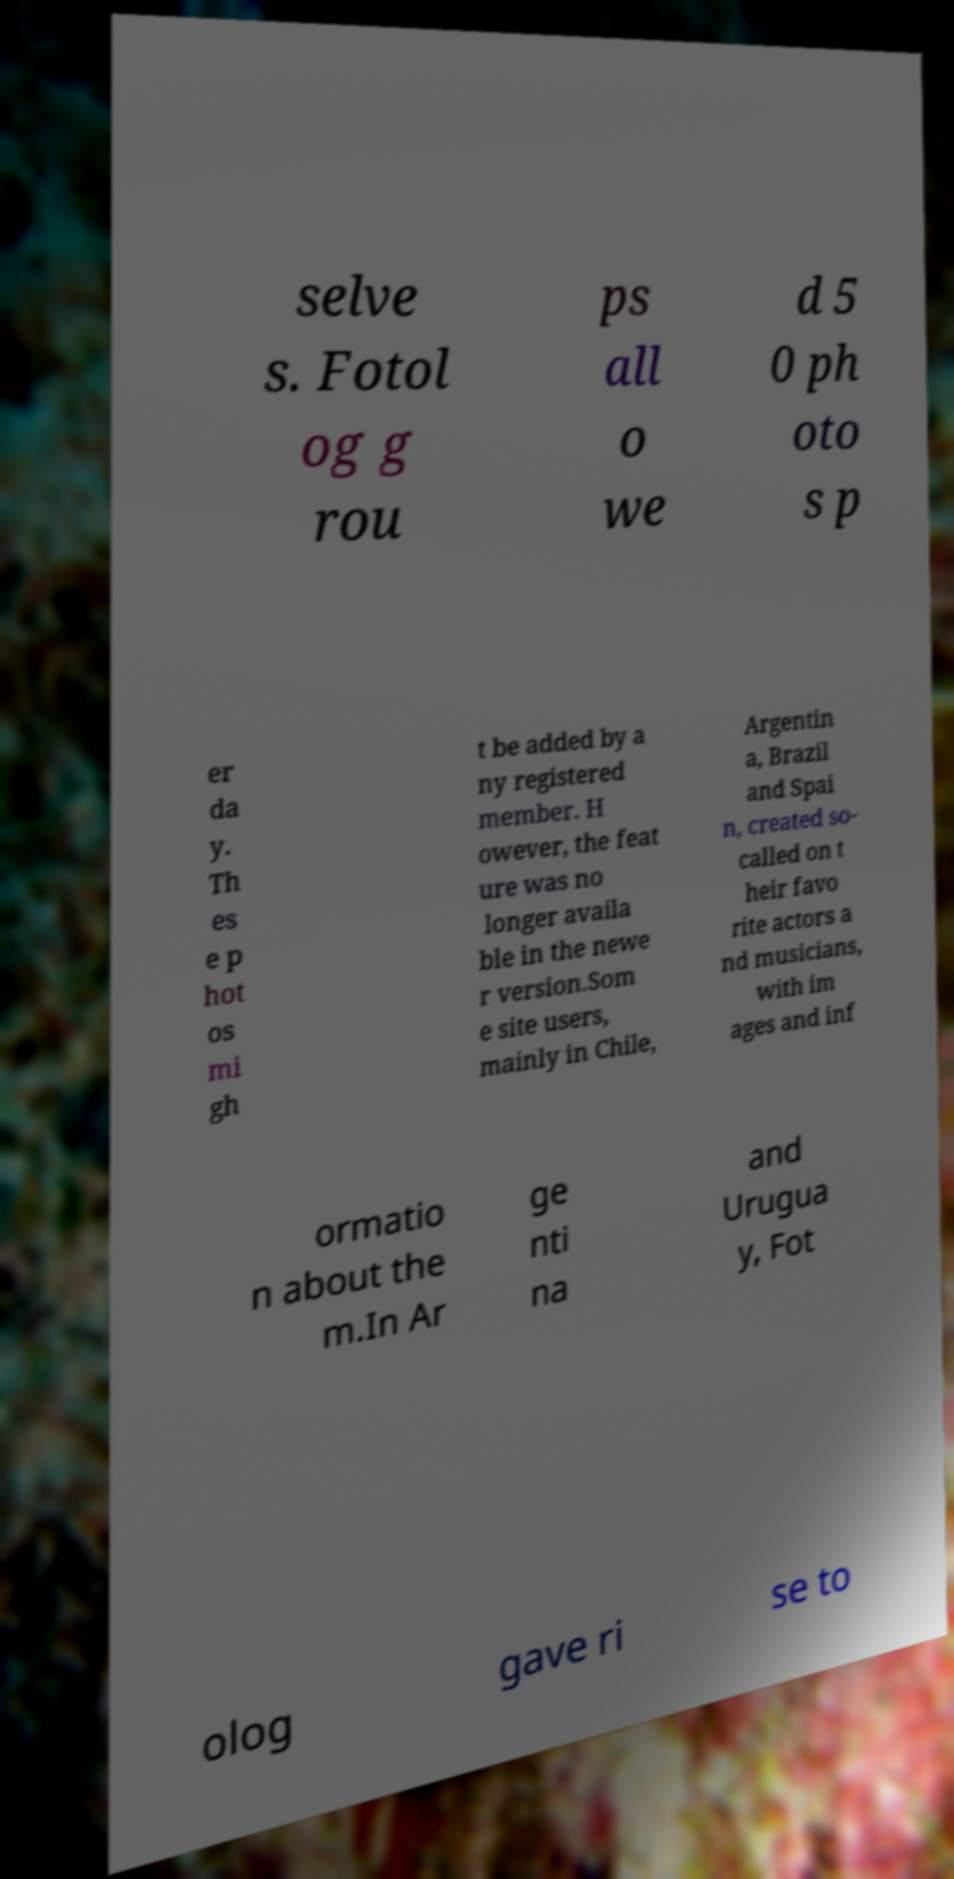What messages or text are displayed in this image? I need them in a readable, typed format. selve s. Fotol og g rou ps all o we d 5 0 ph oto s p er da y. Th es e p hot os mi gh t be added by a ny registered member. H owever, the feat ure was no longer availa ble in the newe r version.Som e site users, mainly in Chile, Argentin a, Brazil and Spai n, created so- called on t heir favo rite actors a nd musicians, with im ages and inf ormatio n about the m.In Ar ge nti na and Urugua y, Fot olog gave ri se to 